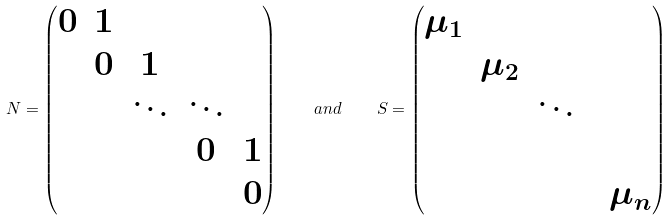<formula> <loc_0><loc_0><loc_500><loc_500>N = \begin{pmatrix} 0 & 1 & & & \\ & 0 & 1 & \\ & & \ddots & \ddots & \\ & & & 0 & 1 \\ & & & & 0 \\ \end{pmatrix} \quad a n d \quad S = \begin{pmatrix} \mu _ { 1 } & & & & \\ & \mu _ { 2 } & & & \\ & & \ddots & & \\ & & & & \\ & & & & \mu _ { n } \\ \end{pmatrix}</formula> 